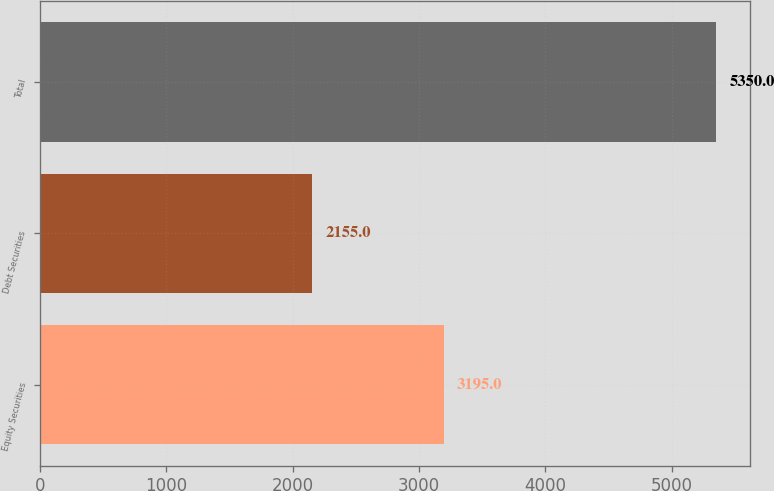Convert chart to OTSL. <chart><loc_0><loc_0><loc_500><loc_500><bar_chart><fcel>Equity Securities<fcel>Debt Securities<fcel>Total<nl><fcel>3195<fcel>2155<fcel>5350<nl></chart> 